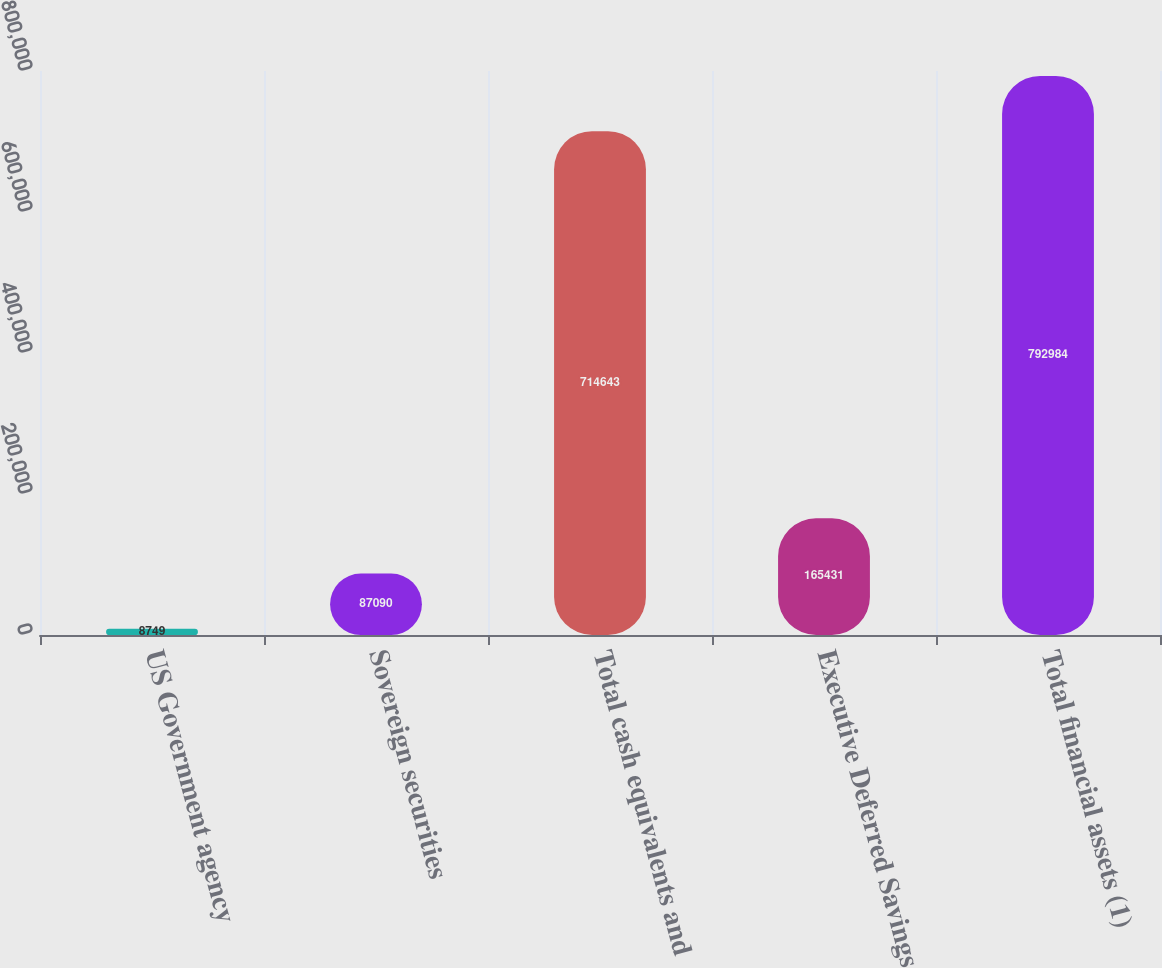<chart> <loc_0><loc_0><loc_500><loc_500><bar_chart><fcel>US Government agency<fcel>Sovereign securities<fcel>Total cash equivalents and<fcel>Executive Deferred Savings<fcel>Total financial assets (1)<nl><fcel>8749<fcel>87090<fcel>714643<fcel>165431<fcel>792984<nl></chart> 